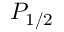Convert formula to latex. <formula><loc_0><loc_0><loc_500><loc_500>P _ { 1 / 2 }</formula> 